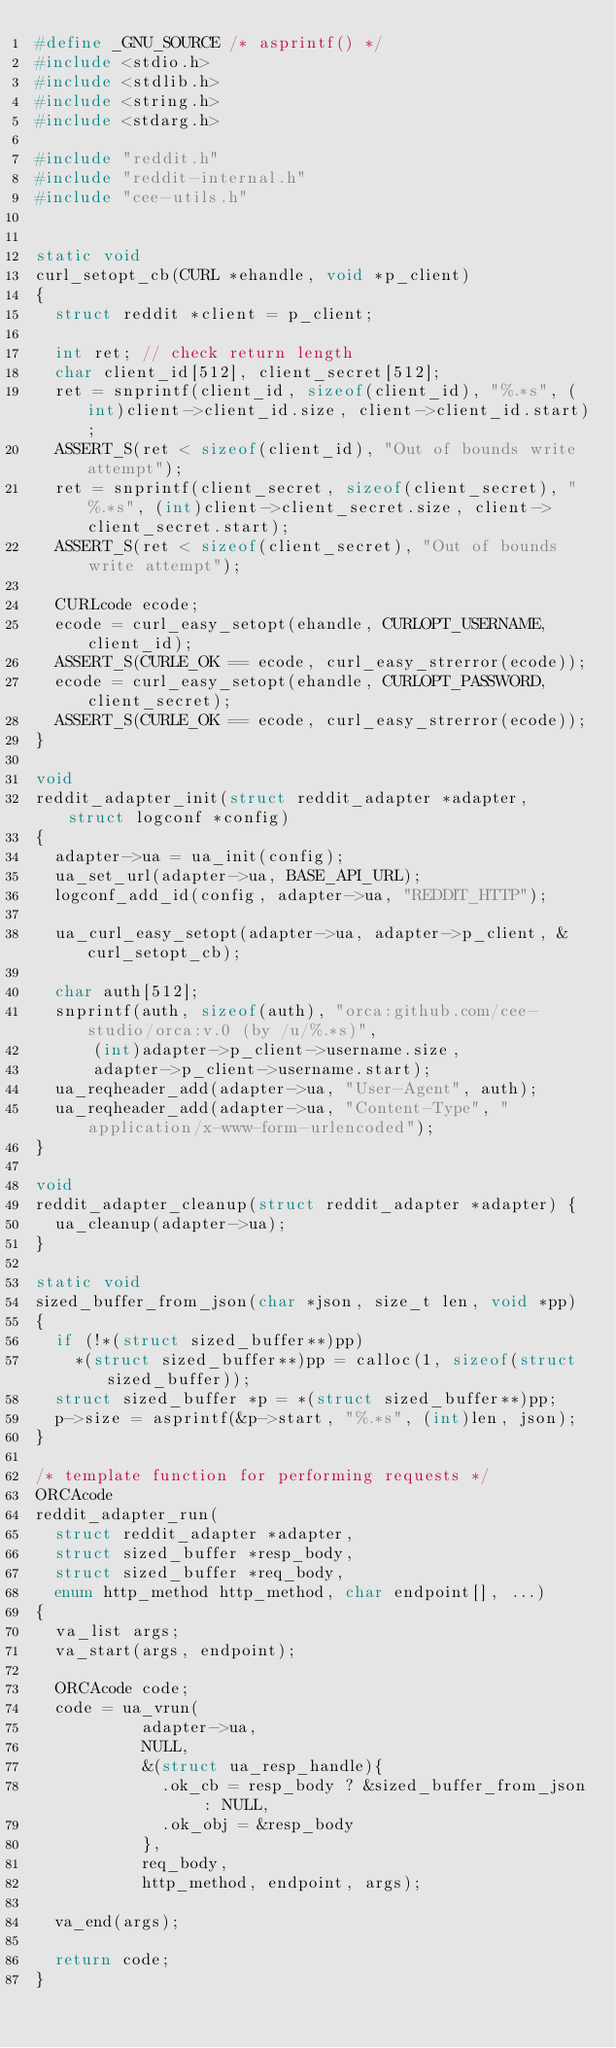<code> <loc_0><loc_0><loc_500><loc_500><_C_>#define _GNU_SOURCE /* asprintf() */
#include <stdio.h>
#include <stdlib.h>
#include <string.h>
#include <stdarg.h>

#include "reddit.h"
#include "reddit-internal.h"
#include "cee-utils.h"


static void
curl_setopt_cb(CURL *ehandle, void *p_client)
{
  struct reddit *client = p_client;

  int ret; // check return length
  char client_id[512], client_secret[512];
  ret = snprintf(client_id, sizeof(client_id), "%.*s", (int)client->client_id.size, client->client_id.start);
  ASSERT_S(ret < sizeof(client_id), "Out of bounds write attempt");
  ret = snprintf(client_secret, sizeof(client_secret), "%.*s", (int)client->client_secret.size, client->client_secret.start);
  ASSERT_S(ret < sizeof(client_secret), "Out of bounds write attempt");

  CURLcode ecode;
  ecode = curl_easy_setopt(ehandle, CURLOPT_USERNAME, client_id);
  ASSERT_S(CURLE_OK == ecode, curl_easy_strerror(ecode));
  ecode = curl_easy_setopt(ehandle, CURLOPT_PASSWORD, client_secret);
  ASSERT_S(CURLE_OK == ecode, curl_easy_strerror(ecode));
}

void
reddit_adapter_init(struct reddit_adapter *adapter, struct logconf *config)
{
  adapter->ua = ua_init(config);
  ua_set_url(adapter->ua, BASE_API_URL);
  logconf_add_id(config, adapter->ua, "REDDIT_HTTP");

  ua_curl_easy_setopt(adapter->ua, adapter->p_client, &curl_setopt_cb);

  char auth[512];
  snprintf(auth, sizeof(auth), "orca:github.com/cee-studio/orca:v.0 (by /u/%.*s)",
      (int)adapter->p_client->username.size,
      adapter->p_client->username.start);
  ua_reqheader_add(adapter->ua, "User-Agent", auth);
  ua_reqheader_add(adapter->ua, "Content-Type", "application/x-www-form-urlencoded");
}

void
reddit_adapter_cleanup(struct reddit_adapter *adapter) {
  ua_cleanup(adapter->ua);
}

static void 
sized_buffer_from_json(char *json, size_t len, void *pp) 
{
  if (!*(struct sized_buffer**)pp) 
    *(struct sized_buffer**)pp = calloc(1, sizeof(struct sized_buffer));
  struct sized_buffer *p = *(struct sized_buffer**)pp;
  p->size = asprintf(&p->start, "%.*s", (int)len, json);
}

/* template function for performing requests */
ORCAcode
reddit_adapter_run(
  struct reddit_adapter *adapter, 
  struct sized_buffer *resp_body,
  struct sized_buffer *req_body,
  enum http_method http_method, char endpoint[], ...)
{
  va_list args;
  va_start(args, endpoint);

  ORCAcode code;
  code = ua_vrun(
           adapter->ua,
           NULL,
           &(struct ua_resp_handle){
             .ok_cb = resp_body ? &sized_buffer_from_json : NULL,
             .ok_obj = &resp_body
           },
           req_body,
           http_method, endpoint, args);

  va_end(args);

  return code;
}
</code> 